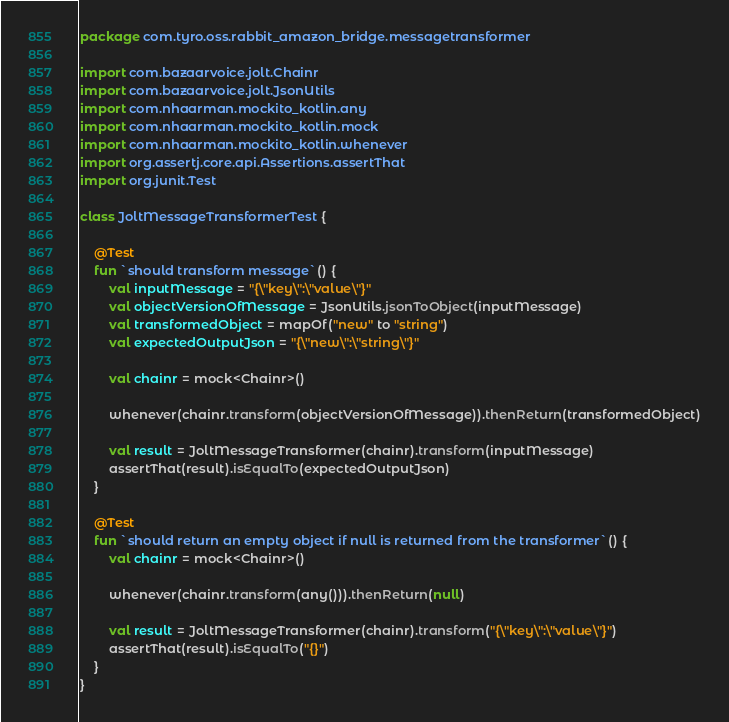<code> <loc_0><loc_0><loc_500><loc_500><_Kotlin_>package com.tyro.oss.rabbit_amazon_bridge.messagetransformer

import com.bazaarvoice.jolt.Chainr
import com.bazaarvoice.jolt.JsonUtils
import com.nhaarman.mockito_kotlin.any
import com.nhaarman.mockito_kotlin.mock
import com.nhaarman.mockito_kotlin.whenever
import org.assertj.core.api.Assertions.assertThat
import org.junit.Test

class JoltMessageTransformerTest {

    @Test
    fun `should transform message`() {
        val inputMessage = "{\"key\":\"value\"}"
        val objectVersionOfMessage = JsonUtils.jsonToObject(inputMessage)
        val transformedObject = mapOf("new" to "string")
        val expectedOutputJson = "{\"new\":\"string\"}"

        val chainr = mock<Chainr>()

        whenever(chainr.transform(objectVersionOfMessage)).thenReturn(transformedObject)

        val result = JoltMessageTransformer(chainr).transform(inputMessage)
        assertThat(result).isEqualTo(expectedOutputJson)
    }

    @Test
    fun `should return an empty object if null is returned from the transformer`() {
        val chainr = mock<Chainr>()

        whenever(chainr.transform(any())).thenReturn(null)

        val result = JoltMessageTransformer(chainr).transform("{\"key\":\"value\"}")
        assertThat(result).isEqualTo("{}")
    }
}
</code> 